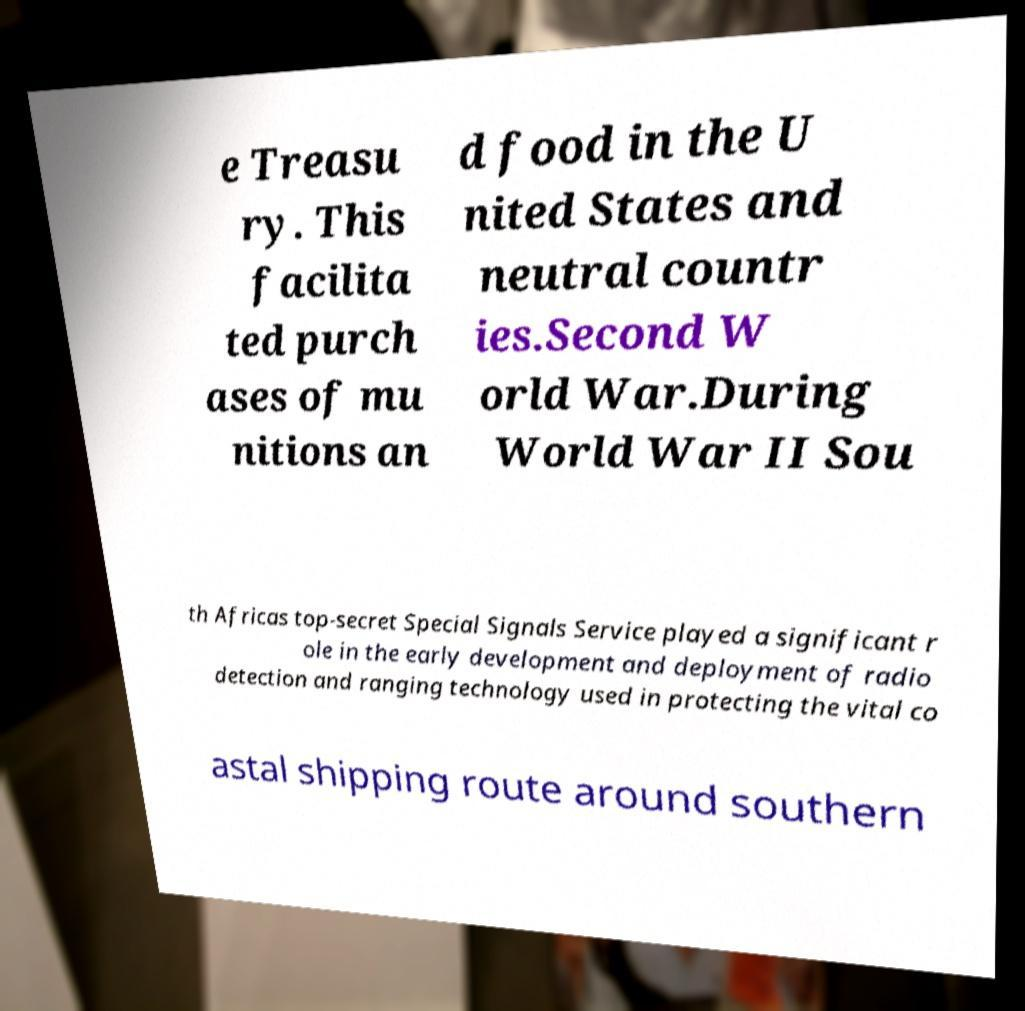For documentation purposes, I need the text within this image transcribed. Could you provide that? e Treasu ry. This facilita ted purch ases of mu nitions an d food in the U nited States and neutral countr ies.Second W orld War.During World War II Sou th Africas top-secret Special Signals Service played a significant r ole in the early development and deployment of radio detection and ranging technology used in protecting the vital co astal shipping route around southern 